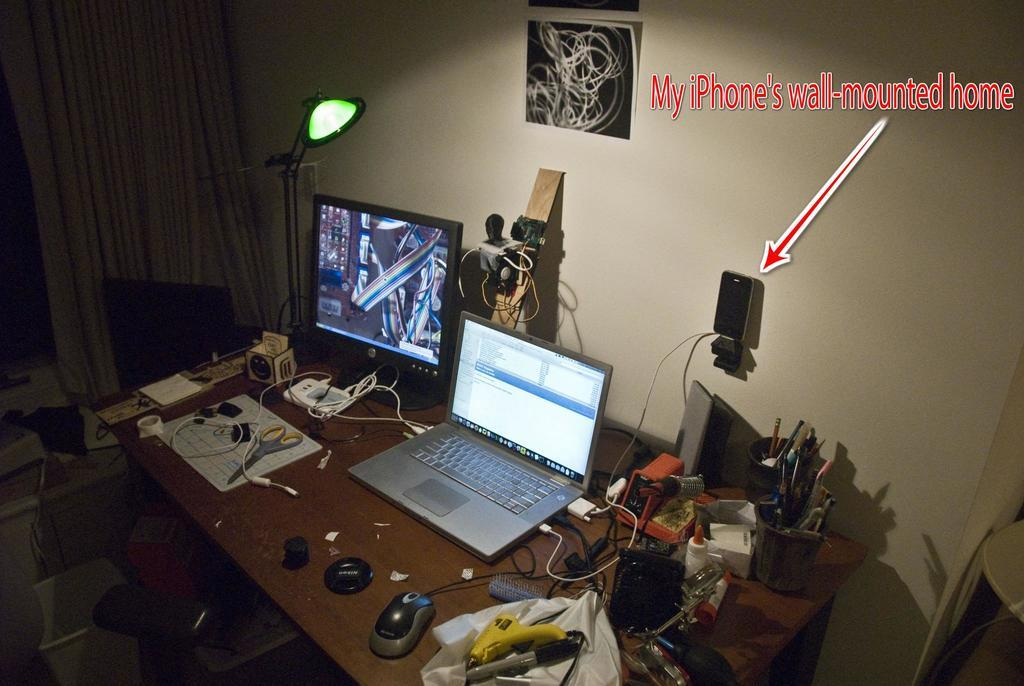<image>
Give a short and clear explanation of the subsequent image. a picture showing a person's iPhone wall mount 